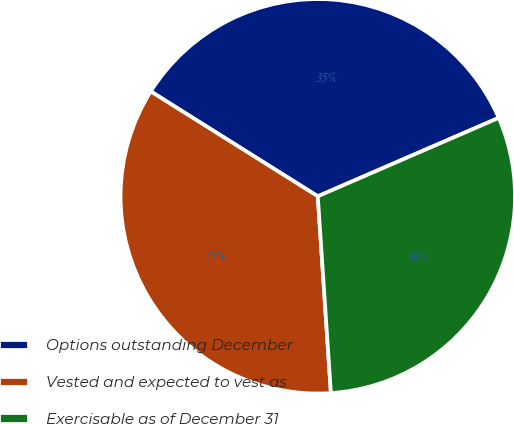<chart> <loc_0><loc_0><loc_500><loc_500><pie_chart><fcel>Options outstanding December<fcel>Vested and expected to vest as<fcel>Exercisable as of December 31<nl><fcel>34.57%<fcel>34.98%<fcel>30.45%<nl></chart> 